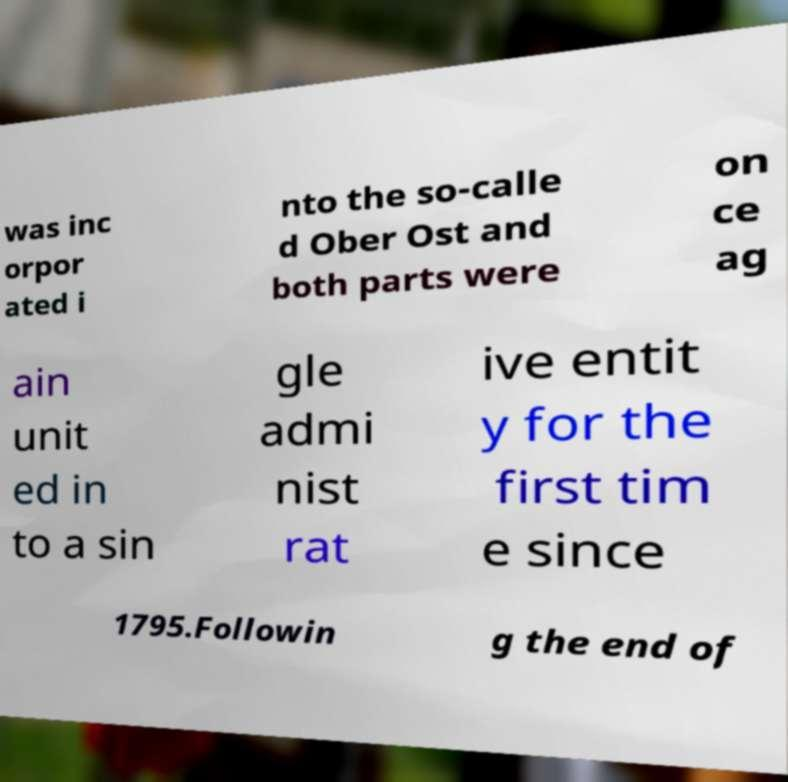Could you extract and type out the text from this image? was inc orpor ated i nto the so-calle d Ober Ost and both parts were on ce ag ain unit ed in to a sin gle admi nist rat ive entit y for the first tim e since 1795.Followin g the end of 